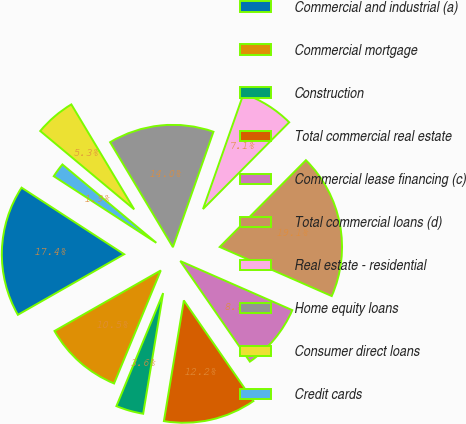Convert chart. <chart><loc_0><loc_0><loc_500><loc_500><pie_chart><fcel>Commercial and industrial (a)<fcel>Commercial mortgage<fcel>Construction<fcel>Total commercial real estate<fcel>Commercial lease financing (c)<fcel>Total commercial loans (d)<fcel>Real estate - residential<fcel>Home equity loans<fcel>Consumer direct loans<fcel>Credit cards<nl><fcel>17.41%<fcel>10.52%<fcel>3.63%<fcel>12.24%<fcel>8.79%<fcel>19.13%<fcel>7.07%<fcel>13.96%<fcel>5.35%<fcel>1.9%<nl></chart> 